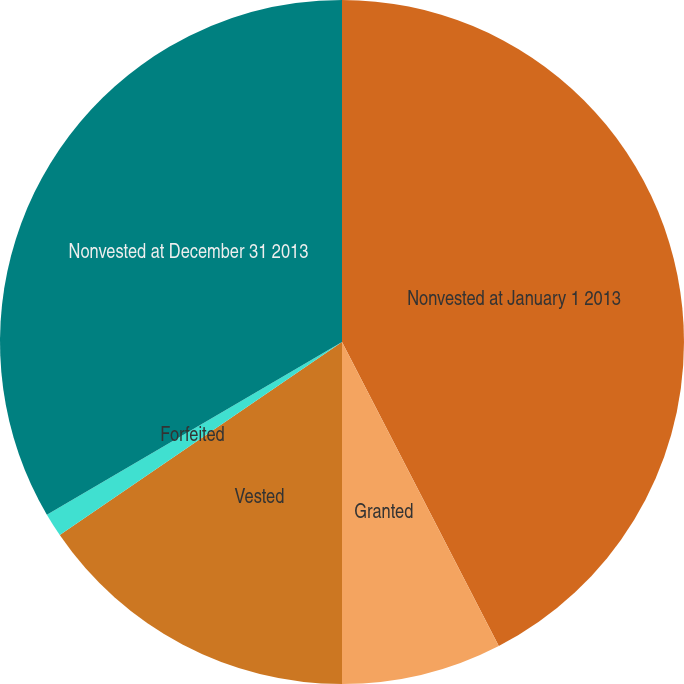Convert chart to OTSL. <chart><loc_0><loc_0><loc_500><loc_500><pie_chart><fcel>Nonvested at January 1 2013<fcel>Granted<fcel>Vested<fcel>Forfeited<fcel>Nonvested at December 31 2013<nl><fcel>42.42%<fcel>7.58%<fcel>15.45%<fcel>1.12%<fcel>33.43%<nl></chart> 